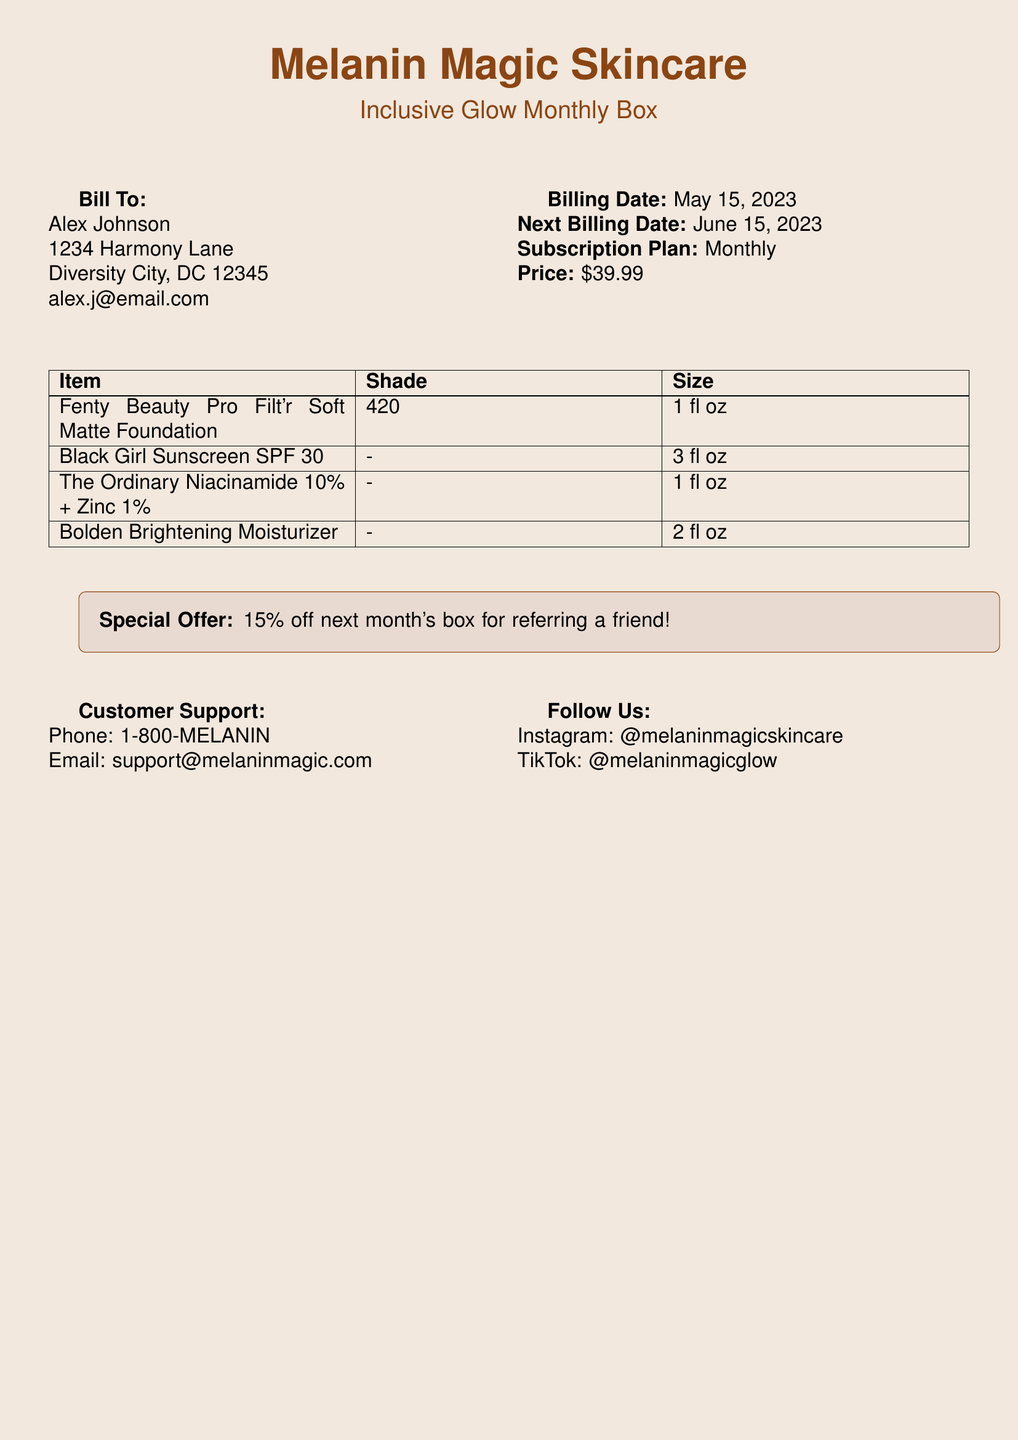What is the name of the subscription box? The name of the subscription box is mentioned under the title, which is "Inclusive Glow Monthly Box."
Answer: Inclusive Glow Monthly Box Who is the billed customer? The customer name is specified under the "Bill To" section, which lists "Alex Johnson."
Answer: Alex Johnson What is the price of the monthly subscription? The price is indicated in the "Price" section of the document, which is set at $39.99.
Answer: $39.99 When is the next billing date? The "Next Billing Date" is stated in the document and is "June 15, 2023."
Answer: June 15, 2023 What is the shade of the Fenty Beauty foundation? The shade for the Fenty Beauty foundation is listed in the item table, which specifies "420."
Answer: 420 What size is the Black Girl Sunscreen? The size of the Black Girl Sunscreen is given in the item table as "3 fl oz."
Answer: 3 fl oz What special offer is available for referrals? The special offer is detailed in the highlighted box, stating "15% off next month's box for referring a friend!"
Answer: 15% off What support email is provided for customer inquiries? The customer support email is listed under the "Customer Support" section, which is "support@melaninmagic.com."
Answer: support@melaninmagic.com 